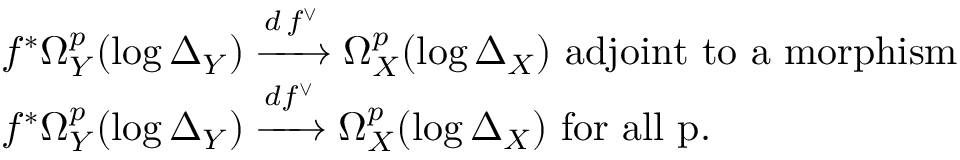Convert formula to latex. <formula><loc_0><loc_0><loc_500><loc_500>\begin{array} { r l } & { f ^ { * } \Omega _ { Y } ^ { p } ( \log \Delta _ { Y } ) \xrightarrow { d \, f ^ { \vee } } \Omega _ { X } ^ { p } ( \log \Delta _ { X } ) a d j o i n t t o a m o r p h i s m } \\ & { f ^ { * } \Omega _ { Y } ^ { p } ( \log \Delta _ { Y } ) \xrightarrow { d f ^ { \vee } } \Omega _ { X } ^ { p } ( \log \Delta _ { X } ) f o r a l l p . } \end{array}</formula> 